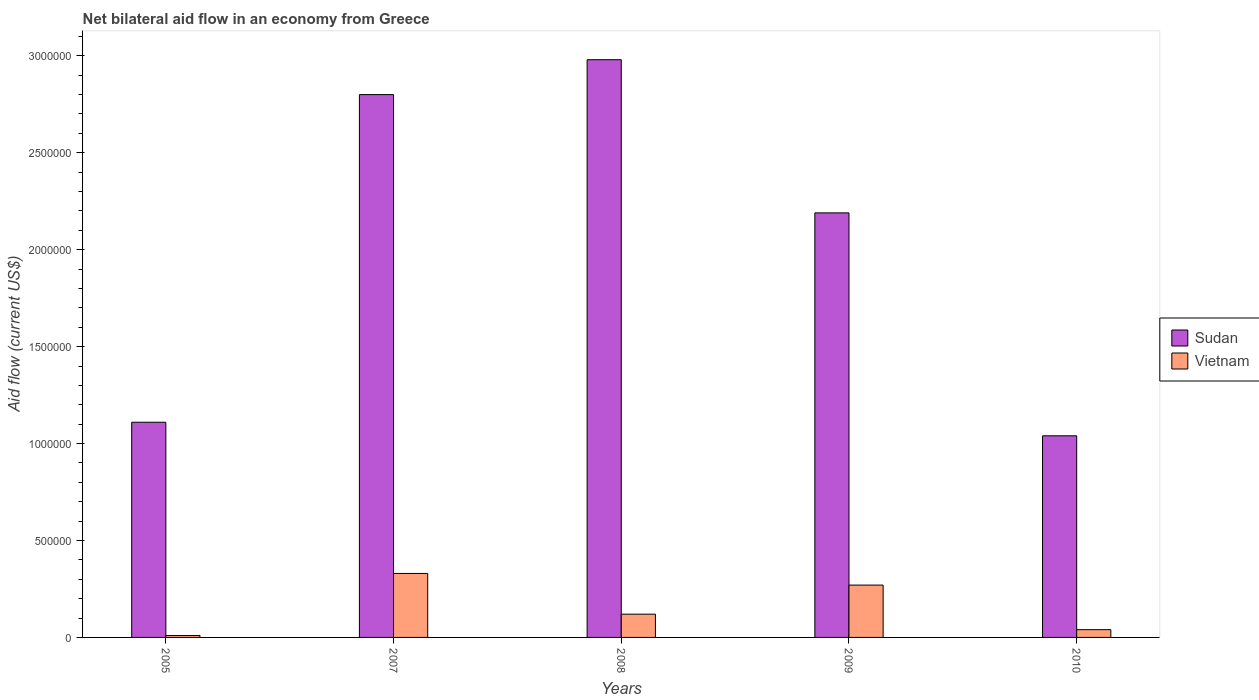Are the number of bars per tick equal to the number of legend labels?
Give a very brief answer. Yes. Are the number of bars on each tick of the X-axis equal?
Offer a terse response. Yes. How many bars are there on the 2nd tick from the right?
Your answer should be very brief. 2. In how many cases, is the number of bars for a given year not equal to the number of legend labels?
Your answer should be compact. 0. What is the net bilateral aid flow in Vietnam in 2010?
Your answer should be compact. 4.00e+04. Across all years, what is the maximum net bilateral aid flow in Sudan?
Ensure brevity in your answer.  2.98e+06. Across all years, what is the minimum net bilateral aid flow in Sudan?
Offer a terse response. 1.04e+06. In which year was the net bilateral aid flow in Vietnam minimum?
Offer a terse response. 2005. What is the total net bilateral aid flow in Vietnam in the graph?
Your answer should be compact. 7.70e+05. What is the difference between the net bilateral aid flow in Vietnam in 2005 and that in 2007?
Offer a terse response. -3.20e+05. What is the difference between the net bilateral aid flow in Vietnam in 2008 and the net bilateral aid flow in Sudan in 2010?
Provide a short and direct response. -9.20e+05. What is the average net bilateral aid flow in Sudan per year?
Your answer should be very brief. 2.02e+06. In the year 2007, what is the difference between the net bilateral aid flow in Sudan and net bilateral aid flow in Vietnam?
Your answer should be very brief. 2.47e+06. What is the ratio of the net bilateral aid flow in Vietnam in 2005 to that in 2007?
Keep it short and to the point. 0.03. What is the difference between the highest and the lowest net bilateral aid flow in Sudan?
Offer a very short reply. 1.94e+06. Is the sum of the net bilateral aid flow in Sudan in 2009 and 2010 greater than the maximum net bilateral aid flow in Vietnam across all years?
Give a very brief answer. Yes. What does the 1st bar from the left in 2005 represents?
Offer a very short reply. Sudan. What does the 2nd bar from the right in 2009 represents?
Keep it short and to the point. Sudan. Are all the bars in the graph horizontal?
Keep it short and to the point. No. How many years are there in the graph?
Your answer should be compact. 5. What is the difference between two consecutive major ticks on the Y-axis?
Offer a very short reply. 5.00e+05. Are the values on the major ticks of Y-axis written in scientific E-notation?
Offer a very short reply. No. Does the graph contain any zero values?
Provide a succinct answer. No. How many legend labels are there?
Your response must be concise. 2. What is the title of the graph?
Your answer should be very brief. Net bilateral aid flow in an economy from Greece. Does "Singapore" appear as one of the legend labels in the graph?
Offer a terse response. No. What is the Aid flow (current US$) of Sudan in 2005?
Your answer should be very brief. 1.11e+06. What is the Aid flow (current US$) of Sudan in 2007?
Offer a terse response. 2.80e+06. What is the Aid flow (current US$) in Sudan in 2008?
Offer a very short reply. 2.98e+06. What is the Aid flow (current US$) in Sudan in 2009?
Your answer should be compact. 2.19e+06. What is the Aid flow (current US$) of Sudan in 2010?
Offer a very short reply. 1.04e+06. Across all years, what is the maximum Aid flow (current US$) of Sudan?
Give a very brief answer. 2.98e+06. Across all years, what is the maximum Aid flow (current US$) in Vietnam?
Give a very brief answer. 3.30e+05. Across all years, what is the minimum Aid flow (current US$) of Sudan?
Your response must be concise. 1.04e+06. Across all years, what is the minimum Aid flow (current US$) of Vietnam?
Your answer should be compact. 10000. What is the total Aid flow (current US$) in Sudan in the graph?
Keep it short and to the point. 1.01e+07. What is the total Aid flow (current US$) in Vietnam in the graph?
Make the answer very short. 7.70e+05. What is the difference between the Aid flow (current US$) in Sudan in 2005 and that in 2007?
Ensure brevity in your answer.  -1.69e+06. What is the difference between the Aid flow (current US$) in Vietnam in 2005 and that in 2007?
Your answer should be compact. -3.20e+05. What is the difference between the Aid flow (current US$) in Sudan in 2005 and that in 2008?
Give a very brief answer. -1.87e+06. What is the difference between the Aid flow (current US$) of Vietnam in 2005 and that in 2008?
Offer a terse response. -1.10e+05. What is the difference between the Aid flow (current US$) of Sudan in 2005 and that in 2009?
Ensure brevity in your answer.  -1.08e+06. What is the difference between the Aid flow (current US$) of Vietnam in 2005 and that in 2010?
Provide a short and direct response. -3.00e+04. What is the difference between the Aid flow (current US$) in Vietnam in 2007 and that in 2008?
Provide a succinct answer. 2.10e+05. What is the difference between the Aid flow (current US$) in Vietnam in 2007 and that in 2009?
Make the answer very short. 6.00e+04. What is the difference between the Aid flow (current US$) of Sudan in 2007 and that in 2010?
Your answer should be very brief. 1.76e+06. What is the difference between the Aid flow (current US$) of Sudan in 2008 and that in 2009?
Ensure brevity in your answer.  7.90e+05. What is the difference between the Aid flow (current US$) of Vietnam in 2008 and that in 2009?
Offer a terse response. -1.50e+05. What is the difference between the Aid flow (current US$) of Sudan in 2008 and that in 2010?
Provide a succinct answer. 1.94e+06. What is the difference between the Aid flow (current US$) of Vietnam in 2008 and that in 2010?
Offer a very short reply. 8.00e+04. What is the difference between the Aid flow (current US$) of Sudan in 2009 and that in 2010?
Your answer should be compact. 1.15e+06. What is the difference between the Aid flow (current US$) in Sudan in 2005 and the Aid flow (current US$) in Vietnam in 2007?
Make the answer very short. 7.80e+05. What is the difference between the Aid flow (current US$) in Sudan in 2005 and the Aid flow (current US$) in Vietnam in 2008?
Your response must be concise. 9.90e+05. What is the difference between the Aid flow (current US$) in Sudan in 2005 and the Aid flow (current US$) in Vietnam in 2009?
Give a very brief answer. 8.40e+05. What is the difference between the Aid flow (current US$) in Sudan in 2005 and the Aid flow (current US$) in Vietnam in 2010?
Ensure brevity in your answer.  1.07e+06. What is the difference between the Aid flow (current US$) of Sudan in 2007 and the Aid flow (current US$) of Vietnam in 2008?
Make the answer very short. 2.68e+06. What is the difference between the Aid flow (current US$) of Sudan in 2007 and the Aid flow (current US$) of Vietnam in 2009?
Give a very brief answer. 2.53e+06. What is the difference between the Aid flow (current US$) of Sudan in 2007 and the Aid flow (current US$) of Vietnam in 2010?
Keep it short and to the point. 2.76e+06. What is the difference between the Aid flow (current US$) in Sudan in 2008 and the Aid flow (current US$) in Vietnam in 2009?
Your answer should be compact. 2.71e+06. What is the difference between the Aid flow (current US$) in Sudan in 2008 and the Aid flow (current US$) in Vietnam in 2010?
Provide a succinct answer. 2.94e+06. What is the difference between the Aid flow (current US$) of Sudan in 2009 and the Aid flow (current US$) of Vietnam in 2010?
Give a very brief answer. 2.15e+06. What is the average Aid flow (current US$) of Sudan per year?
Provide a short and direct response. 2.02e+06. What is the average Aid flow (current US$) in Vietnam per year?
Give a very brief answer. 1.54e+05. In the year 2005, what is the difference between the Aid flow (current US$) of Sudan and Aid flow (current US$) of Vietnam?
Keep it short and to the point. 1.10e+06. In the year 2007, what is the difference between the Aid flow (current US$) of Sudan and Aid flow (current US$) of Vietnam?
Your answer should be compact. 2.47e+06. In the year 2008, what is the difference between the Aid flow (current US$) of Sudan and Aid flow (current US$) of Vietnam?
Provide a succinct answer. 2.86e+06. In the year 2009, what is the difference between the Aid flow (current US$) in Sudan and Aid flow (current US$) in Vietnam?
Keep it short and to the point. 1.92e+06. What is the ratio of the Aid flow (current US$) in Sudan in 2005 to that in 2007?
Offer a terse response. 0.4. What is the ratio of the Aid flow (current US$) in Vietnam in 2005 to that in 2007?
Give a very brief answer. 0.03. What is the ratio of the Aid flow (current US$) in Sudan in 2005 to that in 2008?
Provide a short and direct response. 0.37. What is the ratio of the Aid flow (current US$) of Vietnam in 2005 to that in 2008?
Offer a very short reply. 0.08. What is the ratio of the Aid flow (current US$) in Sudan in 2005 to that in 2009?
Offer a terse response. 0.51. What is the ratio of the Aid flow (current US$) in Vietnam in 2005 to that in 2009?
Provide a succinct answer. 0.04. What is the ratio of the Aid flow (current US$) of Sudan in 2005 to that in 2010?
Give a very brief answer. 1.07. What is the ratio of the Aid flow (current US$) of Sudan in 2007 to that in 2008?
Provide a short and direct response. 0.94. What is the ratio of the Aid flow (current US$) of Vietnam in 2007 to that in 2008?
Ensure brevity in your answer.  2.75. What is the ratio of the Aid flow (current US$) in Sudan in 2007 to that in 2009?
Provide a short and direct response. 1.28. What is the ratio of the Aid flow (current US$) of Vietnam in 2007 to that in 2009?
Your response must be concise. 1.22. What is the ratio of the Aid flow (current US$) in Sudan in 2007 to that in 2010?
Keep it short and to the point. 2.69. What is the ratio of the Aid flow (current US$) of Vietnam in 2007 to that in 2010?
Keep it short and to the point. 8.25. What is the ratio of the Aid flow (current US$) of Sudan in 2008 to that in 2009?
Your response must be concise. 1.36. What is the ratio of the Aid flow (current US$) in Vietnam in 2008 to that in 2009?
Ensure brevity in your answer.  0.44. What is the ratio of the Aid flow (current US$) of Sudan in 2008 to that in 2010?
Ensure brevity in your answer.  2.87. What is the ratio of the Aid flow (current US$) in Sudan in 2009 to that in 2010?
Keep it short and to the point. 2.11. What is the ratio of the Aid flow (current US$) of Vietnam in 2009 to that in 2010?
Offer a very short reply. 6.75. What is the difference between the highest and the second highest Aid flow (current US$) in Sudan?
Give a very brief answer. 1.80e+05. What is the difference between the highest and the lowest Aid flow (current US$) of Sudan?
Give a very brief answer. 1.94e+06. 